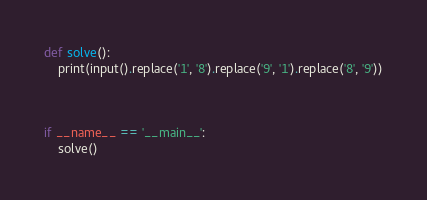<code> <loc_0><loc_0><loc_500><loc_500><_Python_>def solve():
    print(input().replace('1', '8').replace('9', '1').replace('8', '9'))



if __name__ == '__main__':
    solve()
</code> 